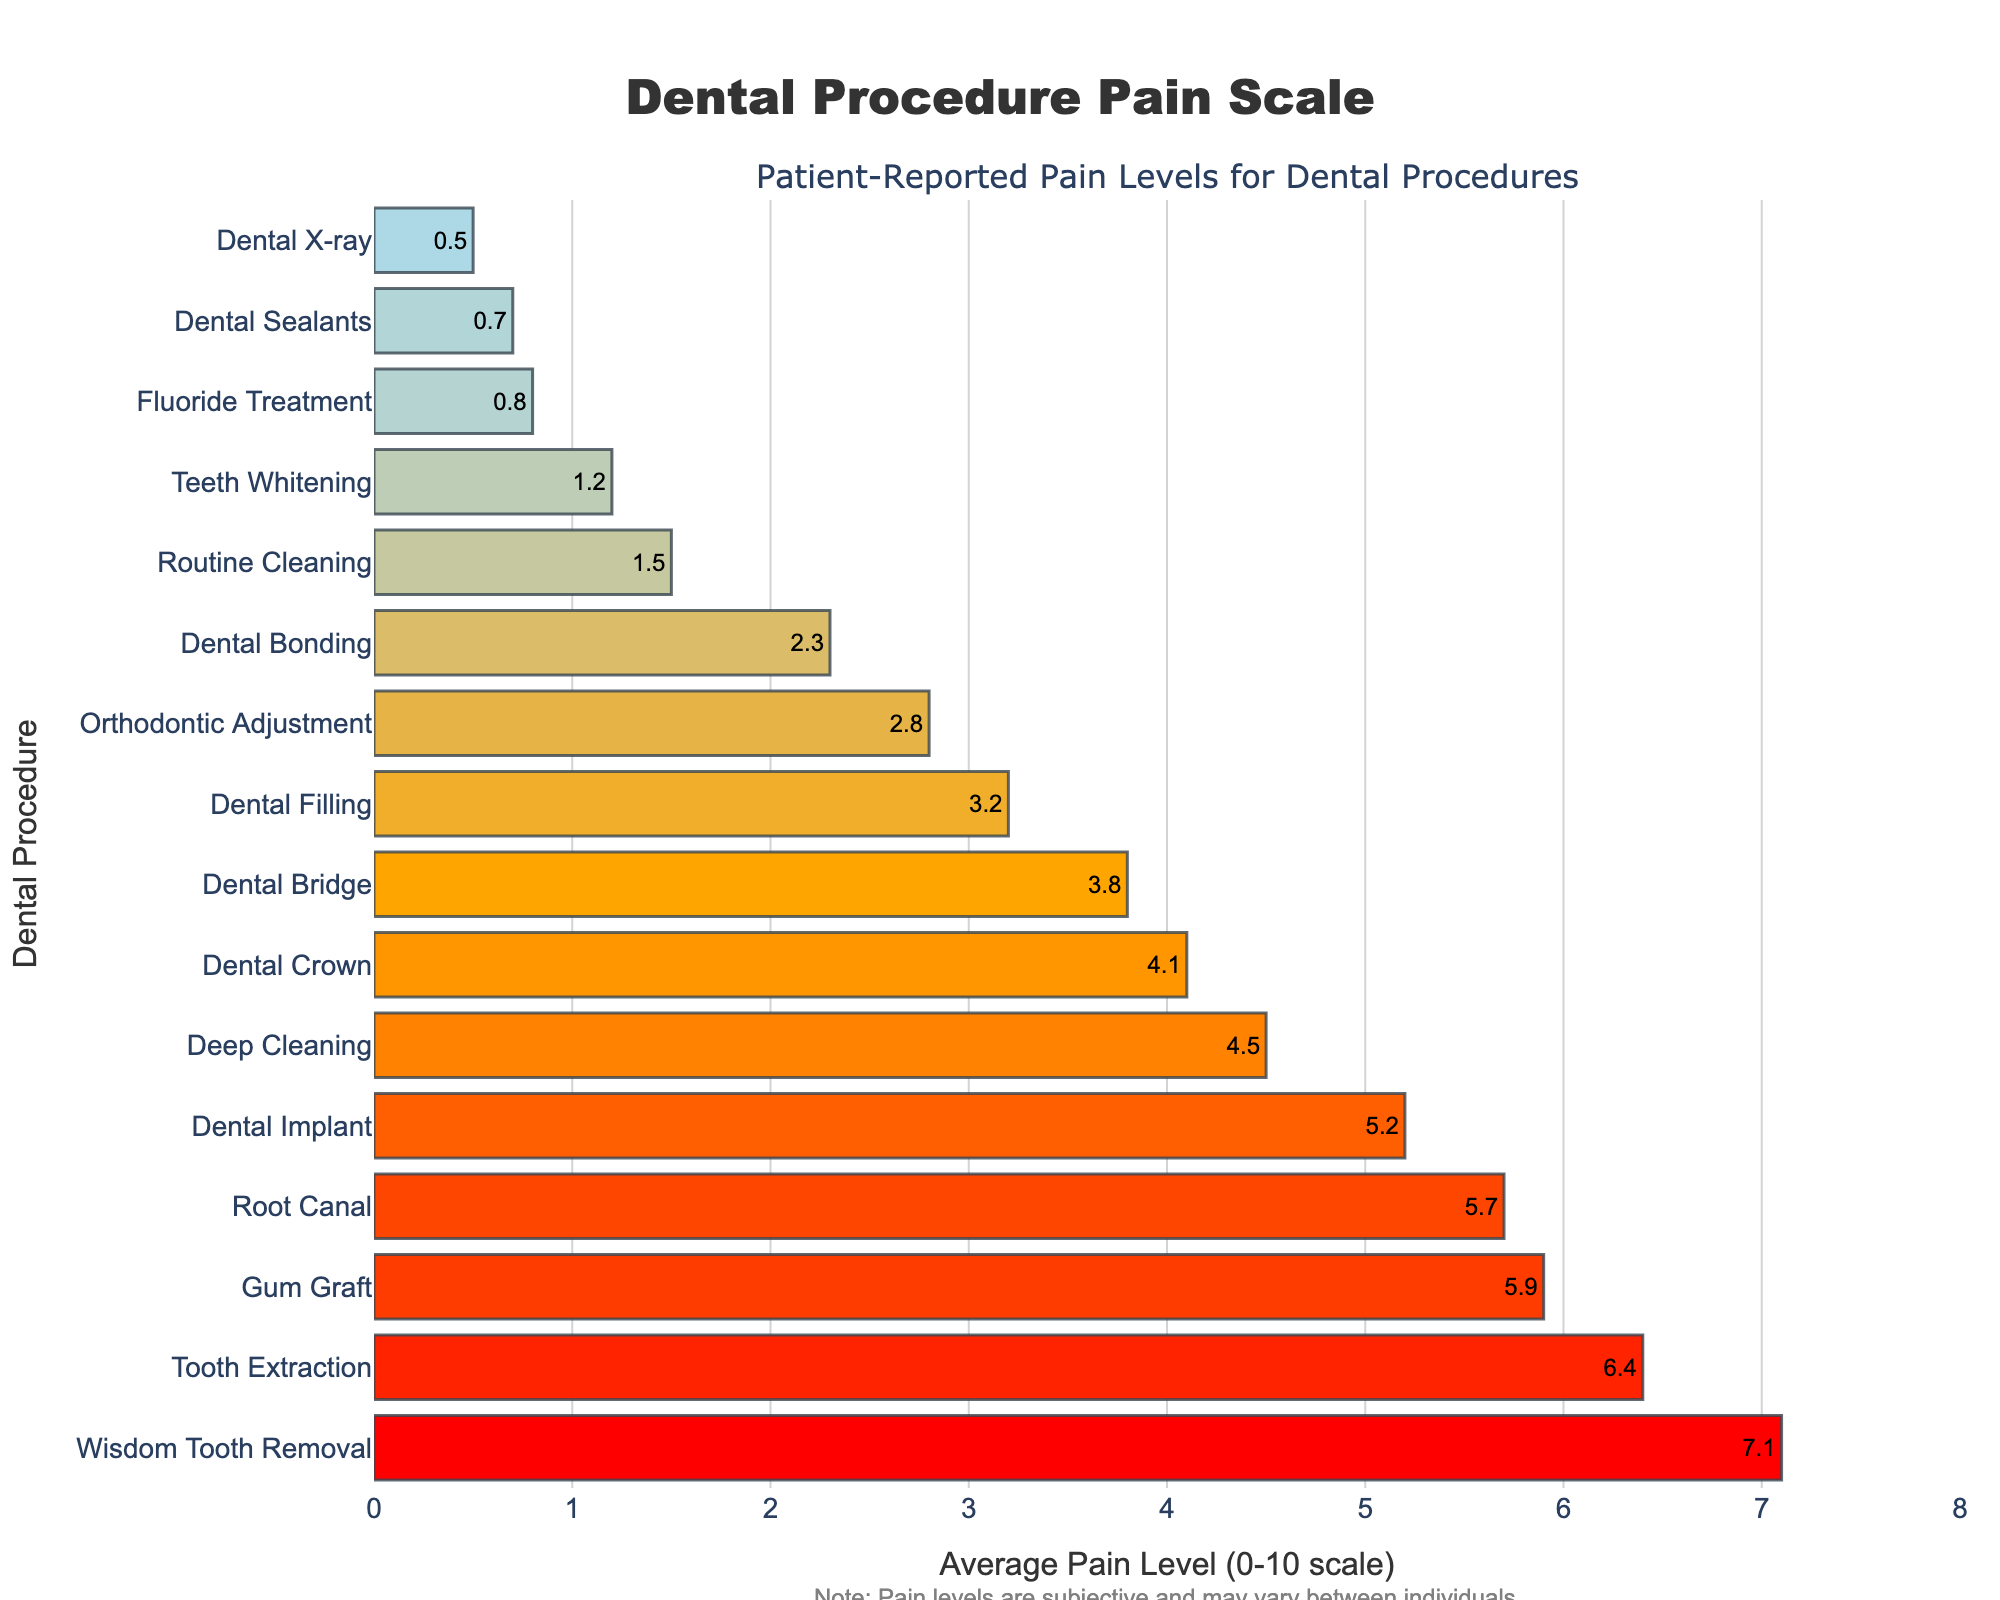What is the average pain level for Dental Fillings and Dental Crowns combined? First, refer to the figure to find the pain levels for Dental Filling (3.2) and Dental Crown (4.1). Add these two values together, which gives 7.3. Then, divide by 2 to find the average: 7.3 / 2.
Answer: 3.65 Which procedure reports the highest average pain level? Look for the bar with the highest value in the figure. The highest average pain level is associated with Wisdom Tooth Removal, with a value of 7.1.
Answer: Wisdom Tooth Removal How does the pain level of a Root Canal compare to that of Deep Cleaning? Find the bars for Root Canal (5.7) and Deep Cleaning (4.5). Compare the two values to see that a Root Canal has a higher average pain level than Deep Cleaning.
Answer: Root Canal has a higher pain level Which procedures have pain levels lower than 1? Identify all bars with values below 1 in the figure. The procedures are Dental X-ray (0.5), Fluoride Treatment (0.8), and Dental Sealants (0.7).
Answer: Dental X-ray, Fluoride Treatment, Dental Sealants What is the color of the bar representing Routine Cleaning? Look at the color gradient represented in the figure. Routine Cleaning has a pain level of 1.5 which falls in the light blue range.
Answer: Light blue How much higher is the pain level for Tooth Extraction compared to Teeth Whitening? Refer to the figure for the pain levels: Tooth Extraction (6.4) and Teeth Whitening (1.2). Subtract the pain level of Teeth Whitening from Tooth Extraction (6.4 - 1.2), which gives 5.2.
Answer: 5.2 What is the average pain level for Orthodontic Adjustment and Dental Bonding? Find the pain levels for Orthodontic Adjustment (2.8) and Dental Bonding (2.3). Sum these values to get 5.1 and then divide by 2 to find the average: 5.1 / 2.
Answer: 2.55 Is Dental Implant pain level closer to that of Gum Graft or Routine Cleaning? Find the pain levels in the figure: Dental Implant (5.2), Gum Graft (5.9), and Routine Cleaning (1.5). Calculate the difference: Dental Implant - Gum Graft = 0.7, Dental Implant - Routine Cleaning = 3.7. The smaller difference shows it's closer to Gum Graft.
Answer: Gum Graft Which procedure has a pain level almost equal to Dental Bridge? Find Dental Bridge pain level (3.8), and identify other bars with similar values. Dental Filling (3.2) and Deep Cleaning (4.5) are close, but Dental Crown (4.1) is the closest.
Answer: Dental Crown 